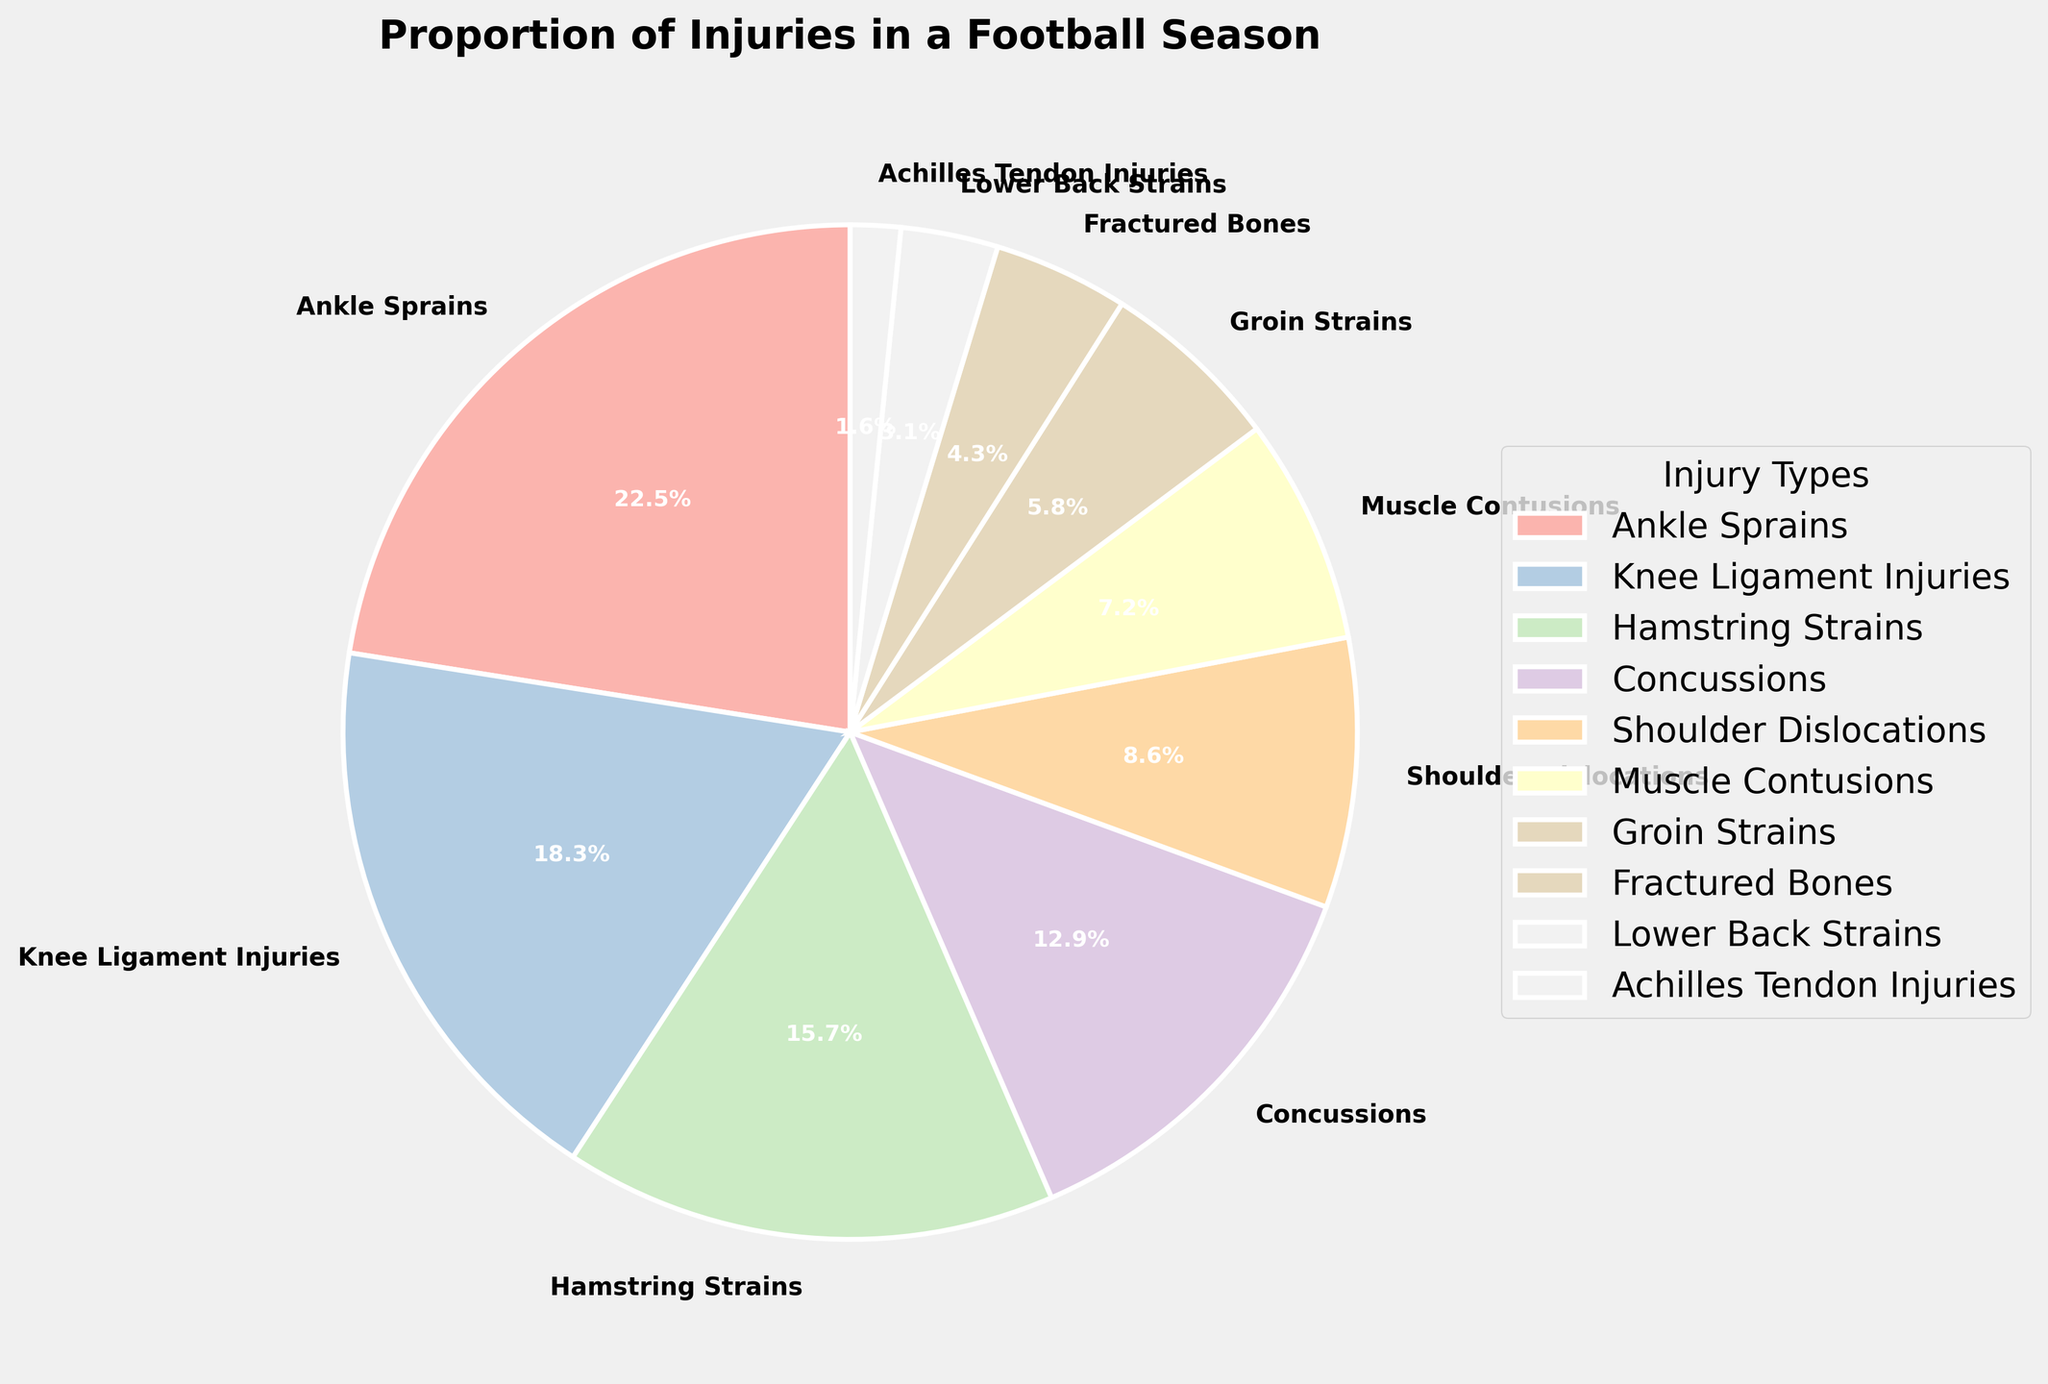What's the most common type of injury in the football season? The chart shows the proportion of different injury types, and the largest wedge represents Ankle Sprains. The value is 22.5%.
Answer: Ankle Sprains Which injury type is less frequent than Groin Strains but more frequent than Lower Back Strains? Groin Strains have a proportion of 5.8%, and Lower Back Strains have 3.1%. Looking at the chart, Fractured Bones have a proportion of 4.3%, which falls between these two values.
Answer: Fractured Bones How much larger is the percentage of Knee Ligament Injuries compared to Muscle Contusions? The percentage of Knee Ligament Injuries is 18.3%, and for Muscle Contusions, it's 7.2%. Subtracting these values gives us 18.3% - 7.2% = 11.1%.
Answer: 11.1% What is the combined percentage of the three least common injury types? Achilles Tendon Injuries are 1.6%, Lower Back Strains are 3.1%, and Fractured Bones are 4.3%. Summing these gives 1.6% + 3.1% + 4.3% = 9.0%.
Answer: 9.0% Do Hamstring Strains and Concussions together account for more than 25% of injuries? Hamstring Strains have a proportion of 15.7%, and Concussions are 12.9%. Adding these together gives 15.7% + 12.9% = 28.6%, which is more than 25%.
Answer: Yes Which injury type accounts for nearly a tenth of all injuries? The chart shows that Concussions account for 12.9% of all injuries, which is close to 10%.
Answer: Concussions What is the visual appearance of the wedge representing Shoulder Dislocations? The wedge for Shoulder Dislocations is light pink, due to the custom pastel color palette used, along with an edge in white.
Answer: Light pink with a white edge Are Muscle Contusions more or less frequent than Hamstring Strains? The chart indicates that Muscle Contusions are 7.2%, while Hamstring Strains are 15.7%. Therefore, Muscle Contusions are less frequent.
Answer: Less frequent Which injury type forms a medium-sized wedge between two larger wedges? The Shoulder Dislocations (8.6%) wedge is located between the larger wedges for Hamstring Strains (15.7%) and Concussions (12.9%), making it a medium-sized wedge.
Answer: Shoulder Dislocations How many types of injuries account for at least 15% of the reported injuries? By observing the chart, Ankle Sprains and Knee Ligament Injuries exceed 15%, as well as Hamstring Strains, making for 3 injury types in total.
Answer: 3 